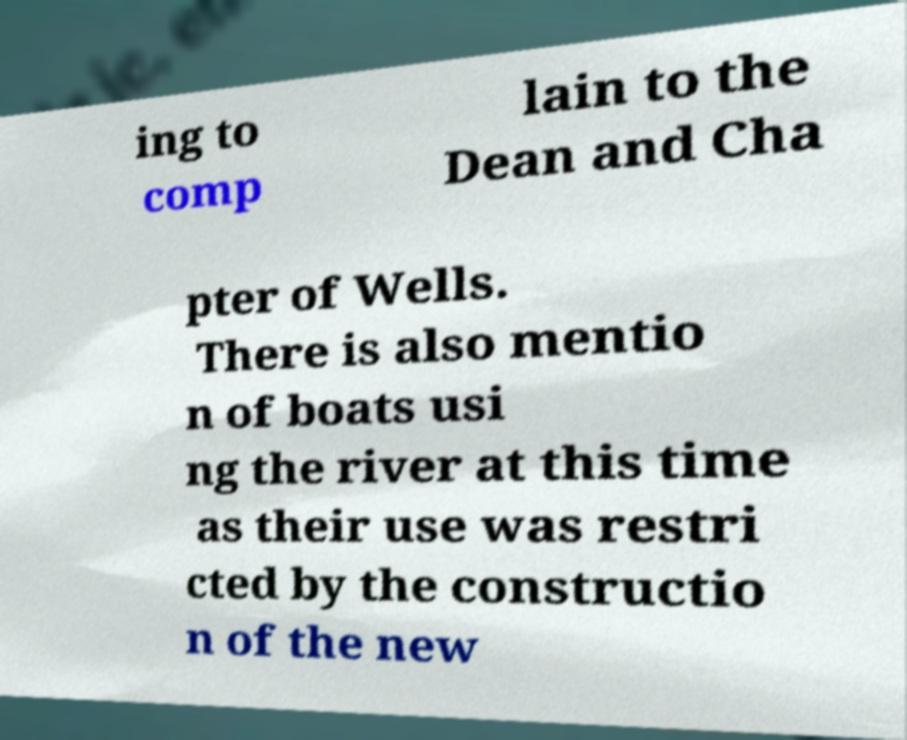Can you accurately transcribe the text from the provided image for me? ing to comp lain to the Dean and Cha pter of Wells. There is also mentio n of boats usi ng the river at this time as their use was restri cted by the constructio n of the new 